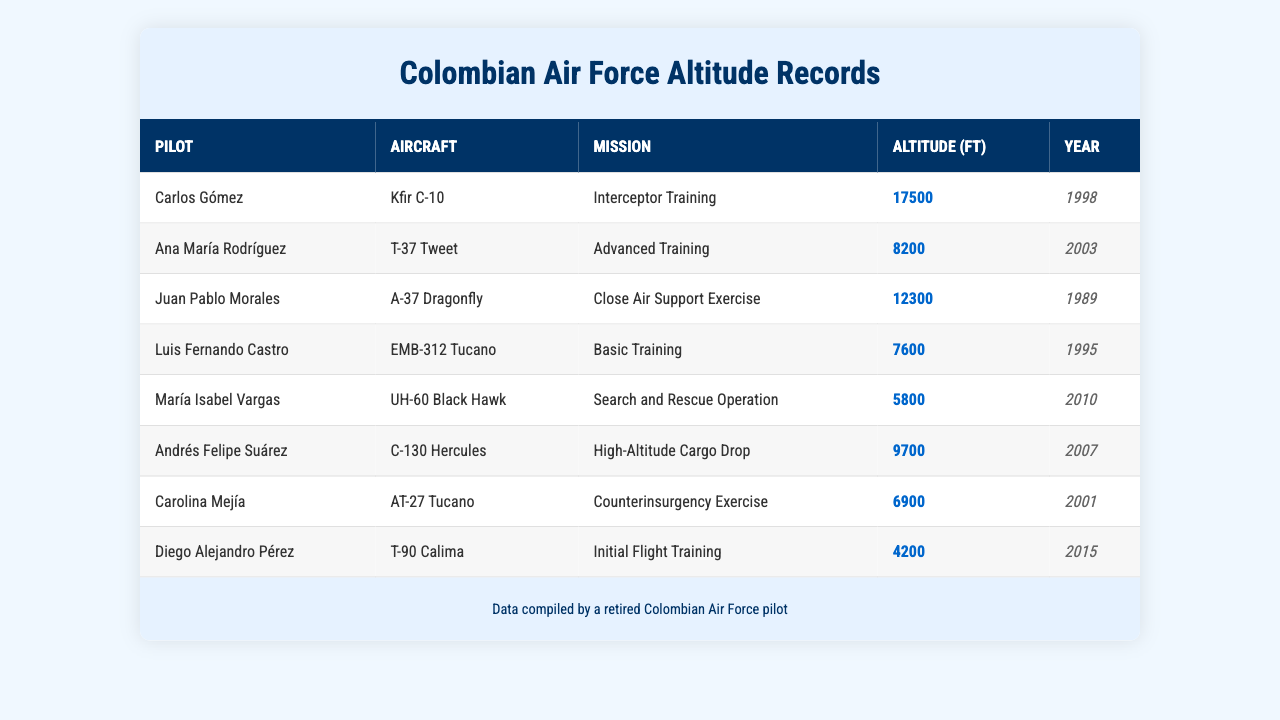What is the highest altitude recorded in the table? The table lists all the altitude records, with the highest being 17500 ft set by Carlos Gómez in 1998.
Answer: 17500 ft Who flew the T-37 Tweet? According to the table, Ana María Rodríguez is the pilot of the T-37 Tweet during the Advanced Training mission.
Answer: Ana María Rodríguez What was the average altitude of the records from the year 2003? In 2003, there is only one record (Ana María Rodríguez) with an altitude of 8200 ft. Therefore, the average is 8200 ft.
Answer: 8200 ft Which pilot had the lowest altitude record? Looking through the records, Diego Alejandro Pérez has the lowest altitude at 4200 ft, achieved in 2015.
Answer: Diego Alejandro Pérez How many pilots achieved altitudes above 10000 ft? The records indicate that three pilots (Carlos Gómez, Juan Pablo Morales, and Andrés Felipe Suárez) achieved altitudes above 10000 ft, with altitudes of 17500 ft, 12300 ft, and 9700 ft, respectively.
Answer: 3 Did any pilot set a record at an altitude of 8000 ft or higher? Yes, there are multiple records set at altitudes of 8000 ft or higher (Carlos Gómez, Ana María Rodríguez, Juan Pablo Morales, and others).
Answer: Yes Which aircraft had the mission with the highest altitude? The Kfir C-10 flown by Carlos Gómez during interceptor training had the highest recorded altitude of 17500 ft.
Answer: Kfir C-10 What was the sum of the altitudes for all records from 1995 to 2010? The sum includes the altitudes: 7600 (Luis Fernando Castro) + 5800 (María Isabel Vargas) = 13400 ft.
Answer: 13400 ft In what year was the Close Air Support Exercise conducted? The table shows the Close Air Support Exercise was conducted in 1989 by pilot Juan Pablo Morales, who flew the A-37 Dragonfly.
Answer: 1989 Is there any record for a mission on a Black Hawk? Yes, María Isabel Vargas's mission was a Search and Rescue Operation, which involved the UH-60 Black Hawk.
Answer: Yes 